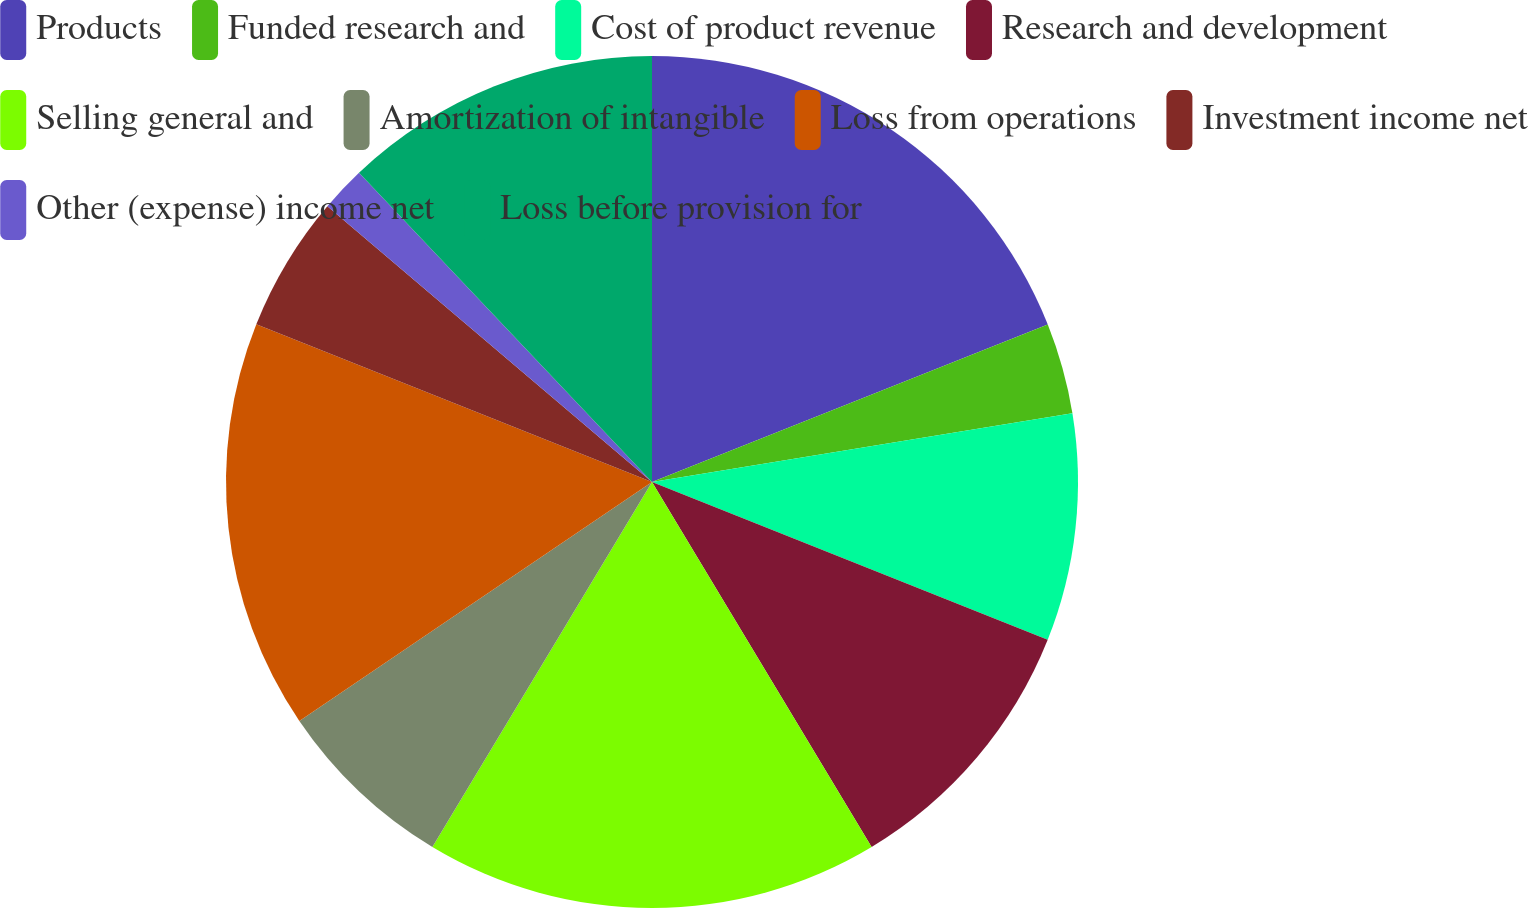<chart> <loc_0><loc_0><loc_500><loc_500><pie_chart><fcel>Products<fcel>Funded research and<fcel>Cost of product revenue<fcel>Research and development<fcel>Selling general and<fcel>Amortization of intangible<fcel>Loss from operations<fcel>Investment income net<fcel>Other (expense) income net<fcel>Loss before provision for<nl><fcel>18.97%<fcel>3.45%<fcel>8.62%<fcel>10.34%<fcel>17.24%<fcel>6.9%<fcel>15.52%<fcel>5.17%<fcel>1.72%<fcel>12.07%<nl></chart> 